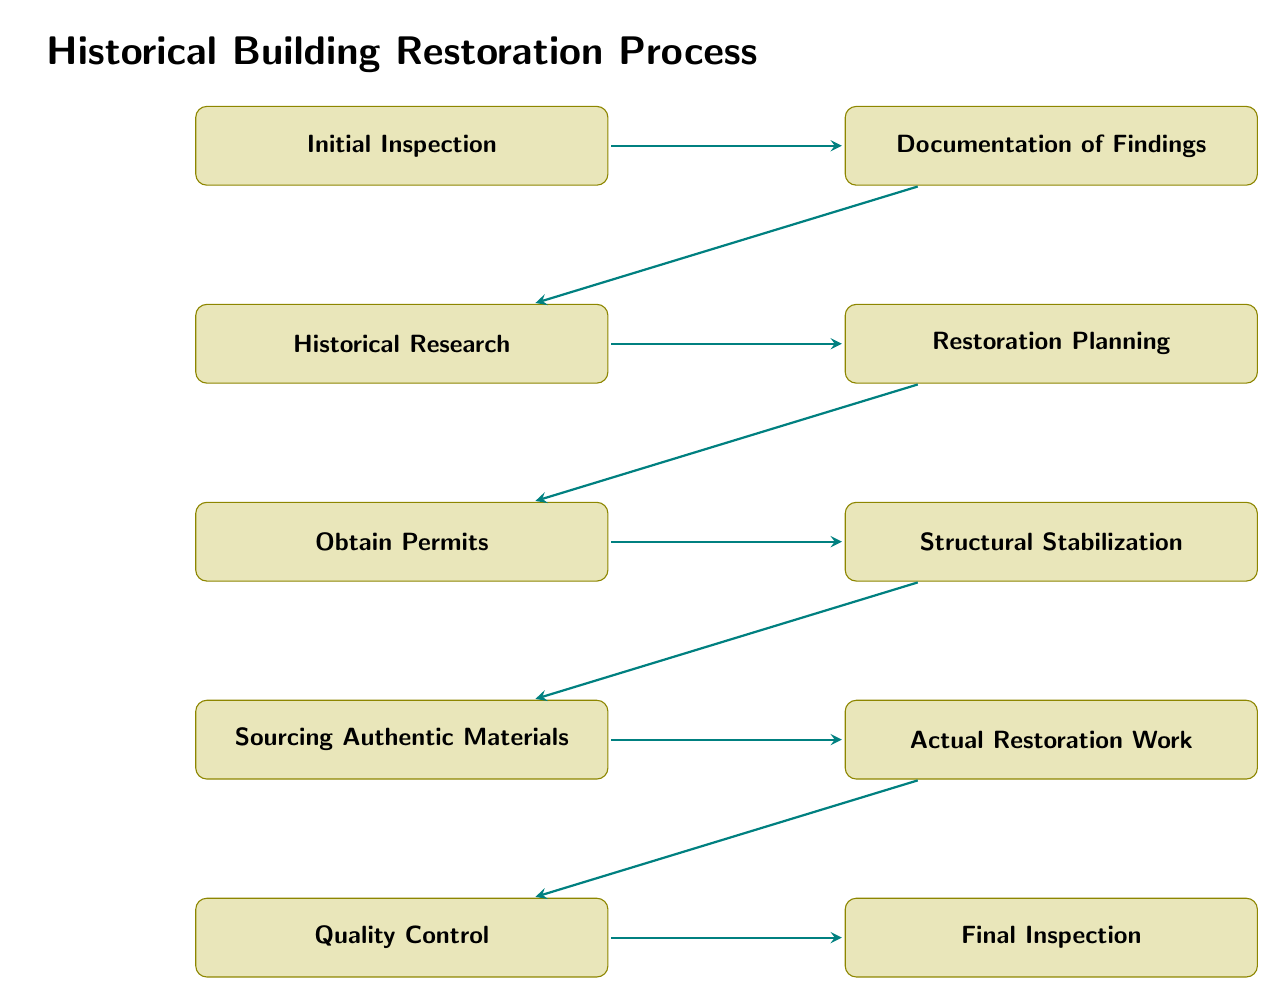What is the first step in the restoration process? The first step in the flowchart is "Initial Inspection." This is indicated as the top node that leads to subsequent steps in the process.
Answer: Initial Inspection How many nodes are in the flowchart? The flowchart comprises ten distinct nodes, which represent different steps in the restoration process, ranging from the initial inspection to the final inspection.
Answer: 10 What comes after "Obtain Permits"? The next step following "Obtain Permits" is "Structural Stabilization." This is identified by the flow from the permits process leading directly to the stabilization process node.
Answer: Structural Stabilization What is the last step in the restoration process? The last step is represented by the node "Final Inspection." This node is the final singular process in the series of steps outlined in the flowchart.
Answer: Final Inspection Which step involves gathering information about the building's original design? The process associated with gathering information about the building's original design is known as "Historical Research." This step directly follows documentation in the flowchart.
Answer: Historical Research Which processes must be completed before "Actual Restoration Work"? Before the "Actual Restoration Work" can commence, the preceding steps include "Sourcing Authentic Materials," "Structural Stabilization," and also "Obtain Permits," indicating that several steps must be completed in sequence.
Answer: Sourcing Authentic Materials, Structural Stabilization, Obtain Permits What is the purpose of the "Quality Control" step? The "Quality Control" step is conducted to inspect and ensure the finished work meets required standards and respects historical integrity. This indicates the importance of maintaining quality during restoration.
Answer: Inspect the finished work How are the steps in the flowchart connected? The steps are connected in a linear fashion, with each step leading to the next in a sequential process. This indicates a systematic approach to restore the historical building.
Answer: Sequentially What is the main focus of the "Restoration Planning" step? The primary focus of the "Restoration Planning" step is to create a detailed plan outlining steps to be taken, materials needed, and timelines, ensuring a structured approach to restoration.
Answer: Create a detailed restoration plan 